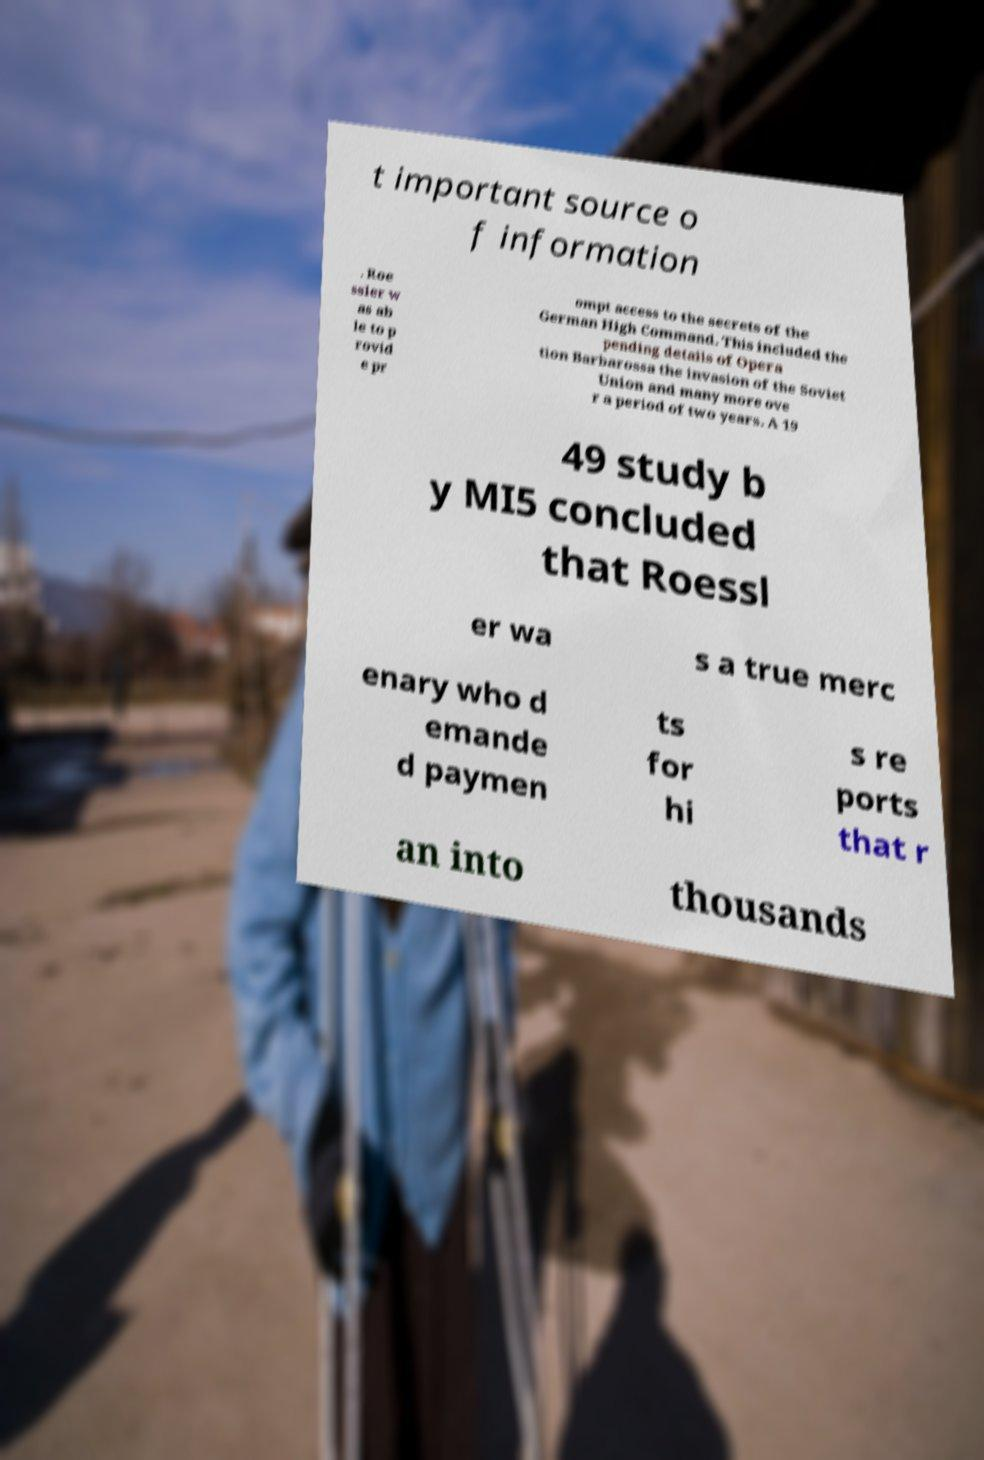Can you read and provide the text displayed in the image?This photo seems to have some interesting text. Can you extract and type it out for me? t important source o f information . Roe ssler w as ab le to p rovid e pr ompt access to the secrets of the German High Command. This included the pending details of Opera tion Barbarossa the invasion of the Soviet Union and many more ove r a period of two years. A 19 49 study b y MI5 concluded that Roessl er wa s a true merc enary who d emande d paymen ts for hi s re ports that r an into thousands 